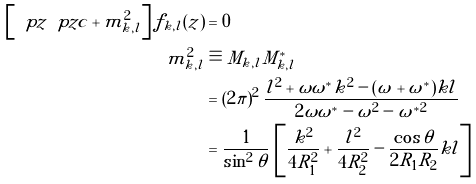Convert formula to latex. <formula><loc_0><loc_0><loc_500><loc_500>\left [ \ p z \ p z c + m ^ { 2 } _ { k , l } \right ] f _ { k , l } ( z ) & = 0 \\ m ^ { 2 } _ { k , l } & \equiv M _ { k , l } M ^ { * } _ { k , l } \\ & = ( 2 \pi ) ^ { 2 } \, \frac { l ^ { 2 } + \omega \omega ^ { * } k ^ { 2 } - ( \omega + \omega ^ { * } ) k l } { 2 \omega \omega ^ { * } - \omega ^ { 2 } - \omega ^ { * 2 } } \\ & = \frac { 1 } { \sin ^ { 2 } \theta } \, \left [ \frac { k ^ { 2 } } { 4 R _ { 1 } ^ { 2 } } + \frac { l ^ { 2 } } { 4 R _ { 2 } ^ { 2 } } - \frac { \cos \theta } { 2 R _ { 1 } R _ { 2 } } k l \right ]</formula> 